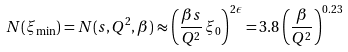<formula> <loc_0><loc_0><loc_500><loc_500>N ( \xi _ { \min } ) = N ( s , Q ^ { 2 } , \beta ) \approx \left ( \frac { \beta s } { Q ^ { 2 } } \, \xi _ { 0 } \right ) ^ { 2 \epsilon } = 3 . 8 \left ( \frac { \beta } { Q ^ { 2 } } \right ) ^ { 0 . 2 3 }</formula> 